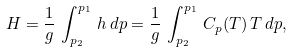<formula> <loc_0><loc_0><loc_500><loc_500>H = \frac { 1 } { g } \, \int _ { p _ { 2 } } ^ { p _ { 1 } } \, h \, d p = \frac { 1 } { g } \, \int _ { p _ { 2 } } ^ { p _ { 1 } } \, C _ { p } ( T ) \, T \, d p ,</formula> 